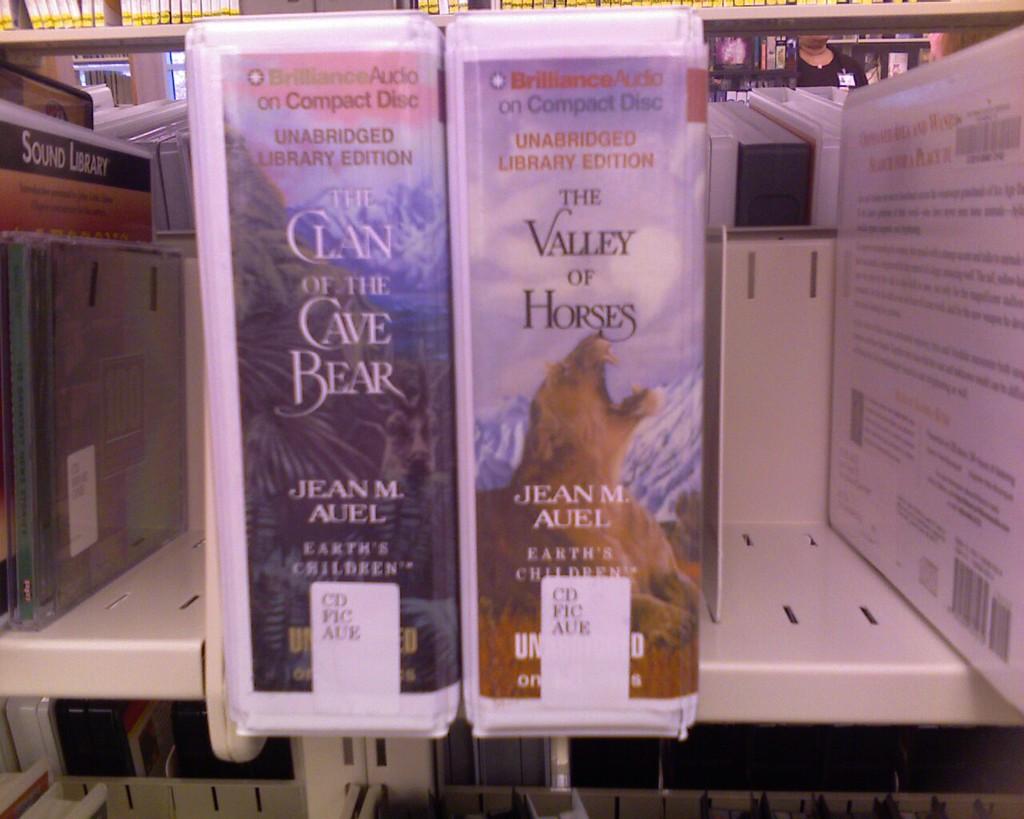What is the authors name of these books?
Ensure brevity in your answer.  Jean m auel. 